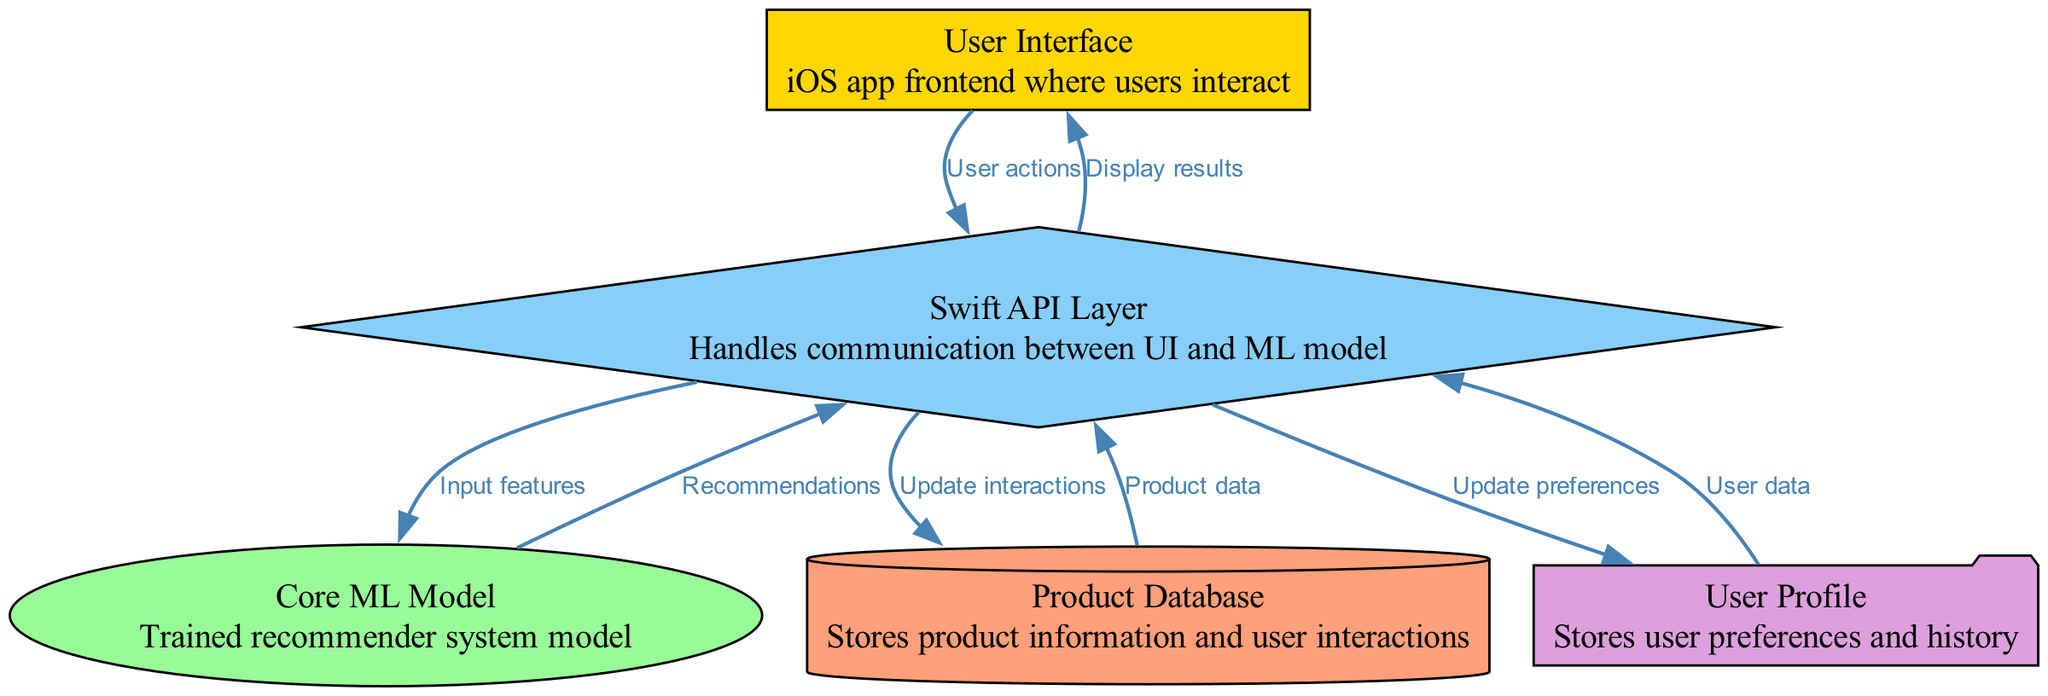What is the main user interaction point in the diagram? The main user interaction point is represented by the "User Interface" node, where users interact with the iOS app to perform actions.
Answer: User Interface How many nodes are in the diagram? The diagram consists of five distinct nodes that represent different components of the recommender system.
Answer: Five What type of data flows from the "Product Database" to the "Swift API Layer"? The data flowing from the "Product Database" to the "Swift API Layer" is labeled as "Product data," which refers to the information about products stored in the database.
Answer: Product data What is the relationship between the "Core ML Model" and "Swift API Layer"? The "Core ML Model" provides recommendations to the "Swift API Layer" based on the input features processed from user interactions and products. This relationship is crucial for generating recommendations for users.
Answer: Recommendations Which node stores user preferences and history? The node that stores user preferences and history is labeled as "User Profile," which is essential for personalizing recommendations based on past user behavior.
Answer: User Profile What action is represented by the edge connecting the "Swift API Layer" to the "User Interface"? The edge connecting these nodes represents the action of "Display results," which indicates that the Swift API Layer sends the recommended products back to the user interface for display to the user.
Answer: Display results How does the "Swift API Layer" update user preferences? The "Swift API Layer" updates user preferences by sending data to the "User Profile," indicating that any changes in user interactions or preferences during the app usage are captured to refine future recommendations.
Answer: Update preferences What type of information is processed as input features to the "Core ML Model"? The "Swift API Layer" sends "Input features" to the "Core ML Model," which typically includes relevant user data and product information needed for generating personalized recommendations.
Answer: Input features What does the "Swift API Layer" do after processing user actions from the "User Interface"? After processing user actions from the "User Interface," the "Swift API Layer" gathers the necessary input features and communicates with the "Core ML Model" to get appropriate recommendations for the user, creating a seamless flow of interaction.
Answer: Input features 